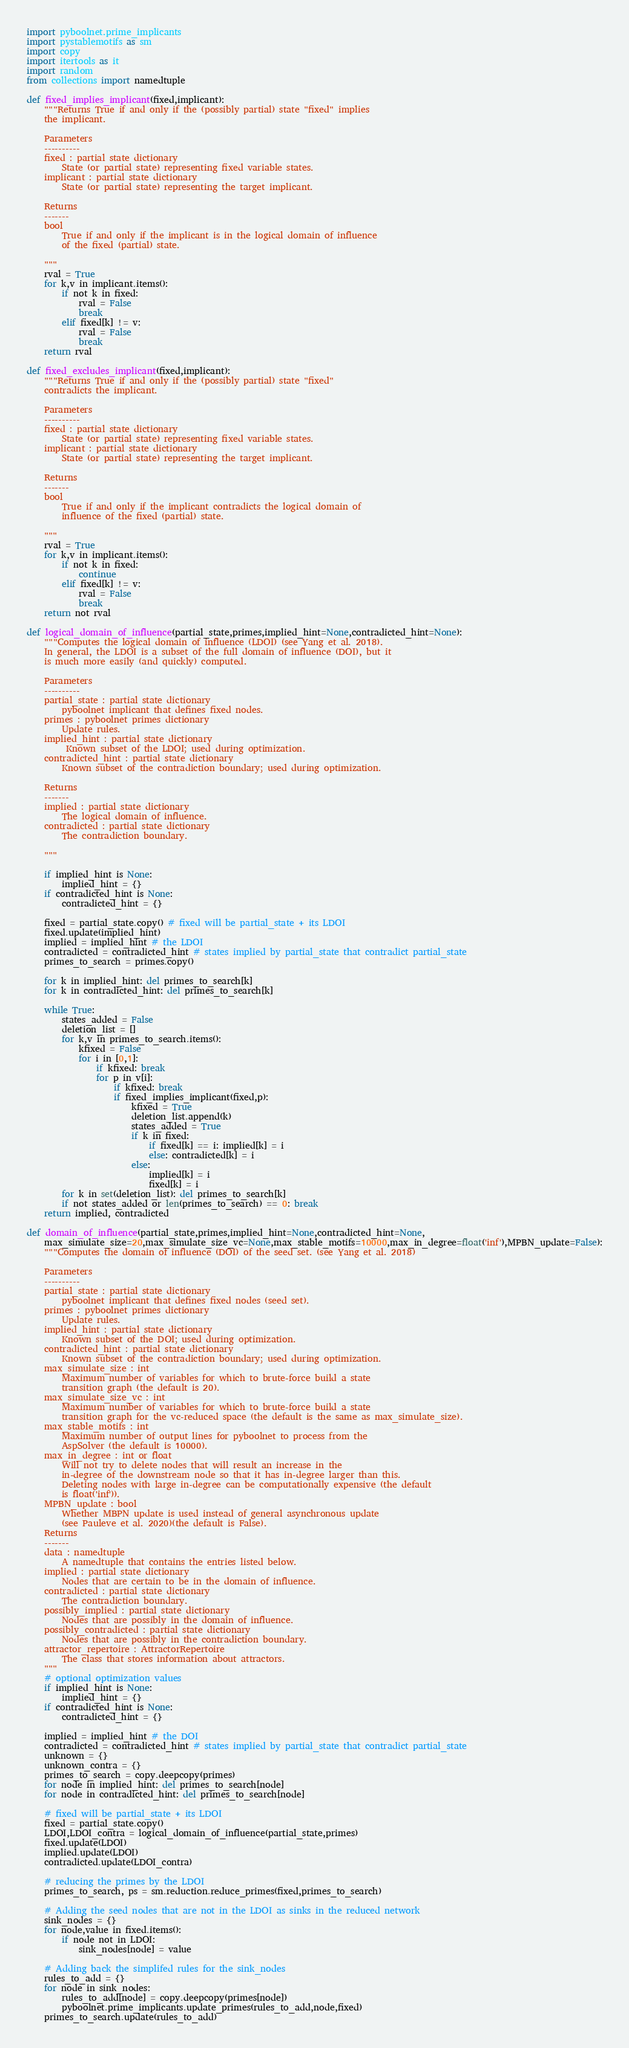<code> <loc_0><loc_0><loc_500><loc_500><_Python_>import pyboolnet.prime_implicants
import pystablemotifs as sm
import copy
import itertools as it
import random
from collections import namedtuple

def fixed_implies_implicant(fixed,implicant):
    """Returns True if and only if the (possibly partial) state "fixed" implies
    the implicant.

    Parameters
    ----------
    fixed : partial state dictionary
        State (or partial state) representing fixed variable states.
    implicant : partial state dictionary
        State (or partial state) representing the target implicant.

    Returns
    -------
    bool
        True if and only if the implicant is in the logical domain of influence
        of the fixed (partial) state.

    """
    rval = True
    for k,v in implicant.items():
        if not k in fixed:
            rval = False
            break
        elif fixed[k] != v:
            rval = False
            break
    return rval

def fixed_excludes_implicant(fixed,implicant):
    """Returns True if and only if the (possibly partial) state "fixed"
    contradicts the implicant.

    Parameters
    ----------
    fixed : partial state dictionary
        State (or partial state) representing fixed variable states.
    implicant : partial state dictionary
        State (or partial state) representing the target implicant.

    Returns
    -------
    bool
        True if and only if the implicant contradicts the logical domain of
        influence of the fixed (partial) state.

    """
    rval = True
    for k,v in implicant.items():
        if not k in fixed:
            continue
        elif fixed[k] != v:
            rval = False
            break
    return not rval

def logical_domain_of_influence(partial_state,primes,implied_hint=None,contradicted_hint=None):
    """Computes the logical domain of influence (LDOI) (see Yang et al. 2018).
    In general, the LDOI is a subset of the full domain of influence (DOI), but it
    is much more easily (and quickly) computed.

    Parameters
    ----------
    partial_state : partial state dictionary
        pyboolnet implicant that defines fixed nodes.
    primes : pyboolnet primes dictionary
        Update rules.
    implied_hint : partial state dictionary
         Known subset of the LDOI; used during optimization.
    contradicted_hint : partial state dictionary
        Known subset of the contradiction boundary; used during optimization.

    Returns
    -------
    implied : partial state dictionary
        The logical domain of influence.
    contradicted : partial state dictionary
        The contradiction boundary.

    """

    if implied_hint is None:
        implied_hint = {}
    if contradicted_hint is None:
        contradicted_hint = {}

    fixed = partial_state.copy() # fixed will be partial_state + its LDOI
    fixed.update(implied_hint)
    implied = implied_hint # the LDOI
    contradicted = contradicted_hint # states implied by partial_state that contradict partial_state
    primes_to_search = primes.copy()

    for k in implied_hint: del primes_to_search[k]
    for k in contradicted_hint: del primes_to_search[k]

    while True:
        states_added = False
        deletion_list = []
        for k,v in primes_to_search.items():
            kfixed = False
            for i in [0,1]:
                if kfixed: break
                for p in v[i]:
                    if kfixed: break
                    if fixed_implies_implicant(fixed,p):
                        kfixed = True
                        deletion_list.append(k)
                        states_added = True
                        if k in fixed:
                            if fixed[k] == i: implied[k] = i
                            else: contradicted[k] = i
                        else:
                            implied[k] = i
                            fixed[k] = i
        for k in set(deletion_list): del primes_to_search[k]
        if not states_added or len(primes_to_search) == 0: break
    return implied, contradicted

def domain_of_influence(partial_state,primes,implied_hint=None,contradicted_hint=None,
    max_simulate_size=20,max_simulate_size_vc=None,max_stable_motifs=10000,max_in_degree=float('inf'),MPBN_update=False):
    """Computes the domain of influence (DOI) of the seed set. (see Yang et al. 2018)

    Parameters
    ----------
    partial_state : partial state dictionary
        pyboolnet implicant that defines fixed nodes (seed set).
    primes : pyboolnet primes dictionary
        Update rules.
    implied_hint : partial state dictionary
        Known subset of the DOI; used during optimization.
    contradicted_hint : partial state dictionary
        Known subset of the contradiction boundary; used during optimization.
    max_simulate_size : int
        Maximum number of variables for which to brute-force build a state
        transition graph (the default is 20).
    max_simulate_size_vc : int
        Maximum number of variables for which to brute-force build a state
        transition graph for the vc-reduced space (the default is the same as max_simulate_size).
    max_stable_motifs : int
        Maximum number of output lines for pyboolnet to process from the
        AspSolver (the default is 10000).
    max_in_degree : int or float
        Will not try to delete nodes that will result an increase in the
        in-degree of the downstream node so that it has in-degree larger than this.
        Deleting nodes with large in-degree can be computationally expensive (the default
        is float('inf')).
    MPBN_update : bool
        Whether MBPN update is used instead of general asynchronous update
        (see Pauleve et al. 2020)(the default is False).
    Returns
    -------
    data : namedtuple
        A namedtuple that contains the entries listed below.
    implied : partial state dictionary
        Nodes that are certain to be in the domain of influence.
    contradicted : partial state dictionary
        The contradiction boundary.
    possibly_implied : partial state dictionary
        Nodes that are possibly in the domain of influence.
    possibly_contradicted : partial state dictionary
        Nodes that are possibly in the contradiction boundary.
    attractor_repertoire : AttractorRepertoire
        The class that stores information about attractors.
    """
    # optional optimization values
    if implied_hint is None:
        implied_hint = {}
    if contradicted_hint is None:
        contradicted_hint = {}

    implied = implied_hint # the DOI
    contradicted = contradicted_hint # states implied by partial_state that contradict partial_state
    unknown = {}
    unknown_contra = {}
    primes_to_search = copy.deepcopy(primes)
    for node in implied_hint: del primes_to_search[node]
    for node in contradicted_hint: del primes_to_search[node]

    # fixed will be partial_state + its LDOI
    fixed = partial_state.copy()
    LDOI,LDOI_contra = logical_domain_of_influence(partial_state,primes)
    fixed.update(LDOI)
    implied.update(LDOI)
    contradicted.update(LDOI_contra)

    # reducing the primes by the LDOI
    primes_to_search, ps = sm.reduction.reduce_primes(fixed,primes_to_search)

    # Adding the seed nodes that are not in the LDOI as sinks in the reduced network
    sink_nodes = {}
    for node,value in fixed.items():
        if node not in LDOI:
            sink_nodes[node] = value

    # Adding back the simplifed rules for the sink_nodes
    rules_to_add = {}
    for node in sink_nodes:
        rules_to_add[node] = copy.deepcopy(primes[node])
        pyboolnet.prime_implicants.update_primes(rules_to_add,node,fixed)
    primes_to_search.update(rules_to_add)</code> 